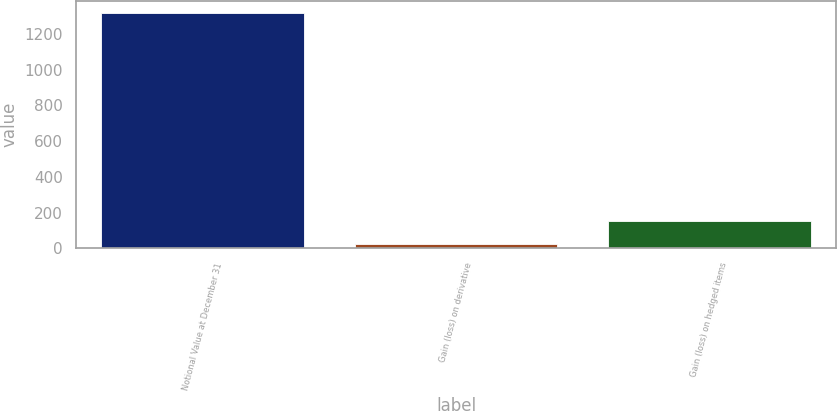<chart> <loc_0><loc_0><loc_500><loc_500><bar_chart><fcel>Notional Value at December 31<fcel>Gain (loss) on derivative<fcel>Gain (loss) on hedged items<nl><fcel>1320<fcel>24<fcel>153.6<nl></chart> 